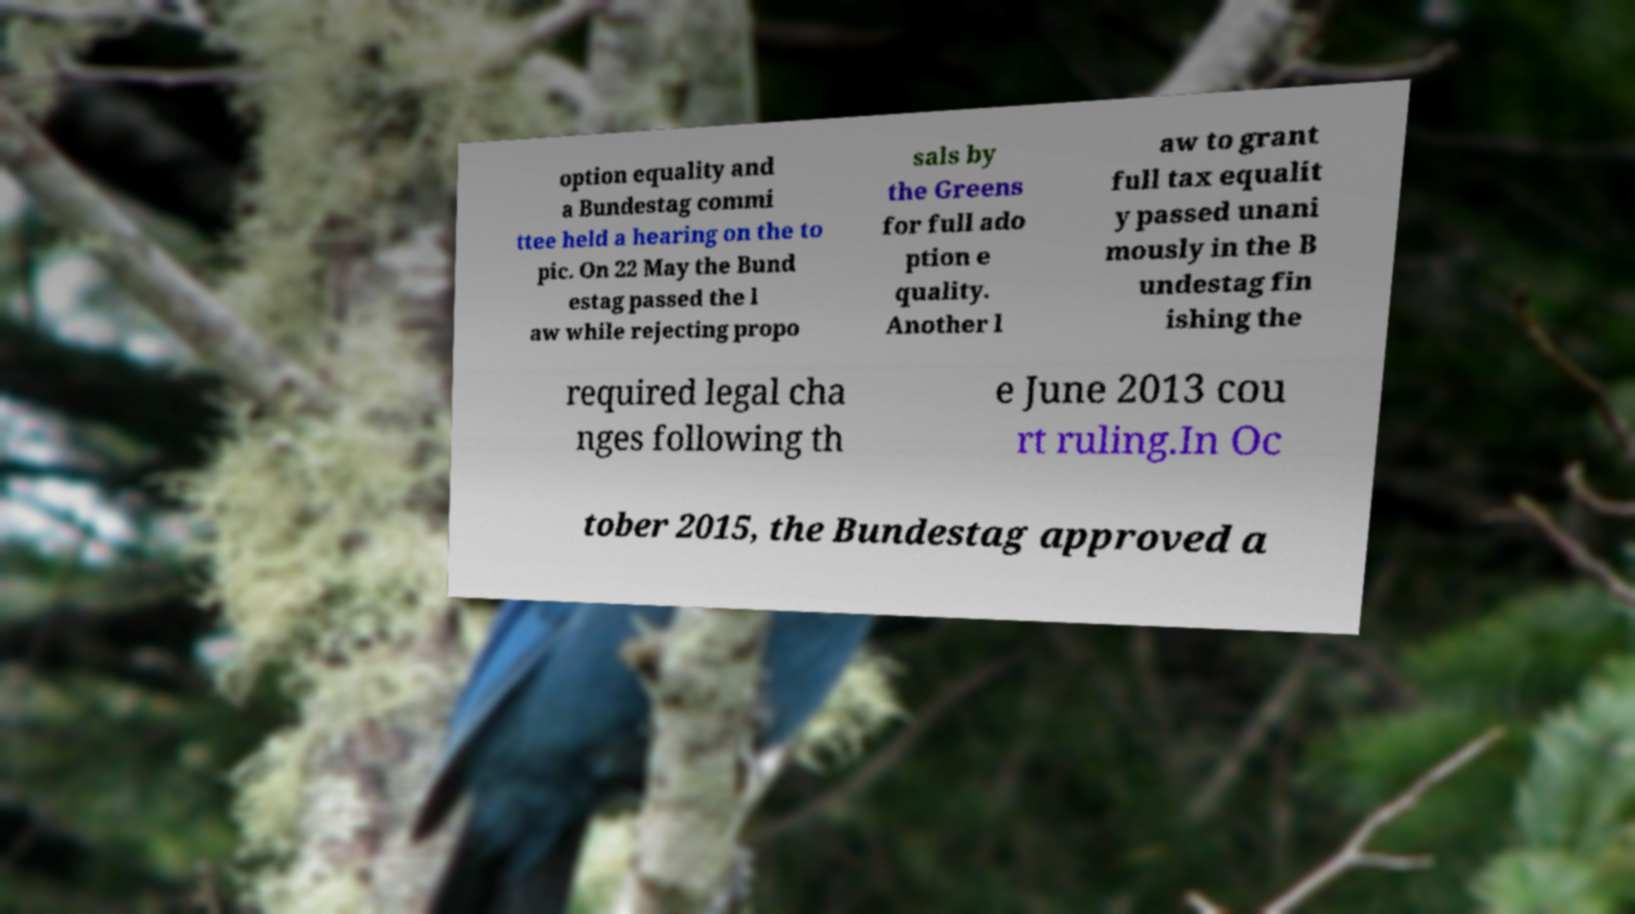Could you extract and type out the text from this image? option equality and a Bundestag commi ttee held a hearing on the to pic. On 22 May the Bund estag passed the l aw while rejecting propo sals by the Greens for full ado ption e quality. Another l aw to grant full tax equalit y passed unani mously in the B undestag fin ishing the required legal cha nges following th e June 2013 cou rt ruling.In Oc tober 2015, the Bundestag approved a 